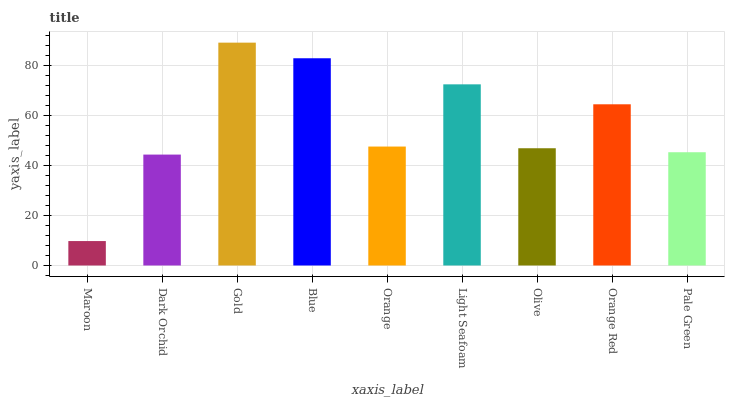Is Maroon the minimum?
Answer yes or no. Yes. Is Gold the maximum?
Answer yes or no. Yes. Is Dark Orchid the minimum?
Answer yes or no. No. Is Dark Orchid the maximum?
Answer yes or no. No. Is Dark Orchid greater than Maroon?
Answer yes or no. Yes. Is Maroon less than Dark Orchid?
Answer yes or no. Yes. Is Maroon greater than Dark Orchid?
Answer yes or no. No. Is Dark Orchid less than Maroon?
Answer yes or no. No. Is Orange the high median?
Answer yes or no. Yes. Is Orange the low median?
Answer yes or no. Yes. Is Blue the high median?
Answer yes or no. No. Is Maroon the low median?
Answer yes or no. No. 